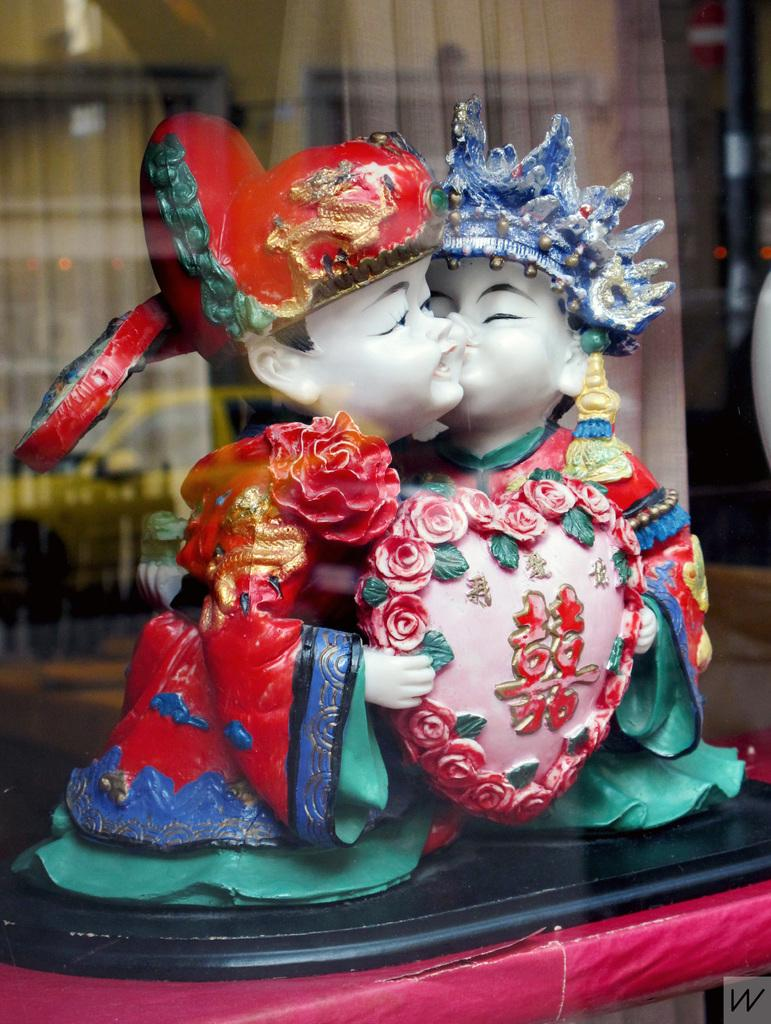What is the main subject in the image? There is a statue in the image. Where is the statue located? The statue is placed on a surface. What can be seen in the background of the image? There is a glass window in the image. Are there any window treatments present in the image? Yes, there are curtains associated with the glass window. What type of shirt is the statue wearing in the image? The statue is not a living being and therefore cannot wear a shirt. The statue is made of a material like stone or metal and does not have clothing. 